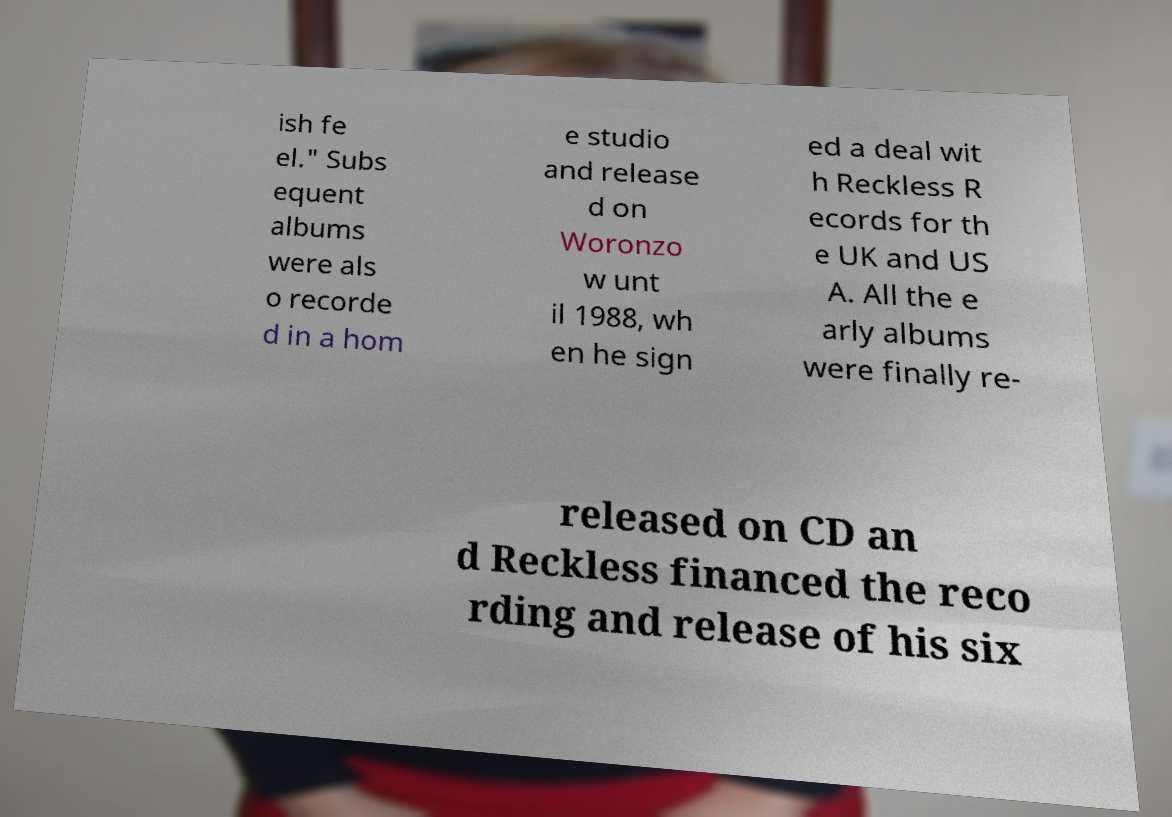Please read and relay the text visible in this image. What does it say? ish fe el." Subs equent albums were als o recorde d in a hom e studio and release d on Woronzo w unt il 1988, wh en he sign ed a deal wit h Reckless R ecords for th e UK and US A. All the e arly albums were finally re- released on CD an d Reckless financed the reco rding and release of his six 